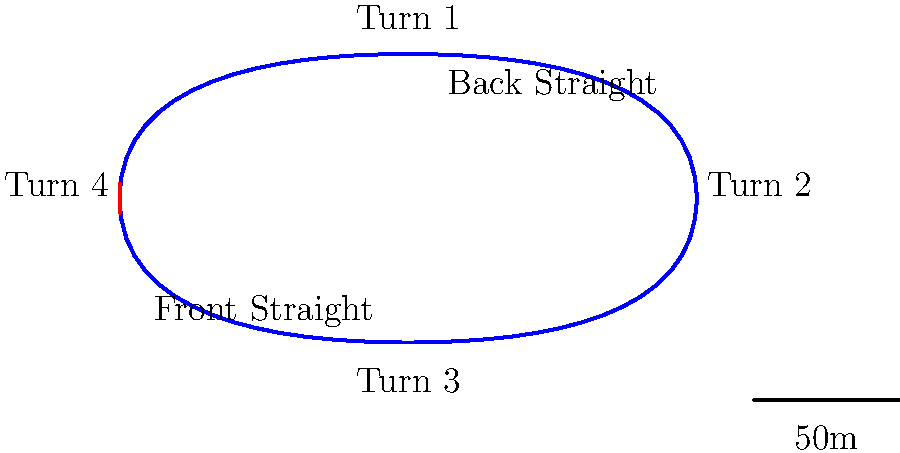Based on the race track diagram, which turn is likely to have the greatest impact on overall lap times, and why? To determine which turn has the greatest impact on lap times, we need to analyze the track layout:

1. Turn 1: This is a sharp turn after the front straight. Cars will need to brake heavily, potentially losing significant speed.

2. Turn 2: This appears to be a gentler turn, allowing cars to carry more speed through it.

3. Turn 3: Similar to Turn 1, this is a sharp turn at the end of the back straight. Cars will need to brake heavily here as well.

4. Turn 4: This seems to be a gentler turn leading onto the front straight.

The turns that require the most braking and have the biggest speed differential between entry and exit will have the greatest impact on lap times. In this case, Turns 1 and 3 are the sharpest and come after long straights where cars can reach high speeds.

Between these two, Turn 3 is likely to have the greatest impact because:

1. It comes at the end of the back straight, which appears longer than the front straight, allowing cars to reach higher speeds.
2. It leads into the front straight, meaning any mistake or loss of speed here will affect the car's speed along the entire front straight.

The ability to brake late, turn quickly, and accelerate out of Turn 3 will be crucial for achieving fast lap times on this track.
Answer: Turn 3 